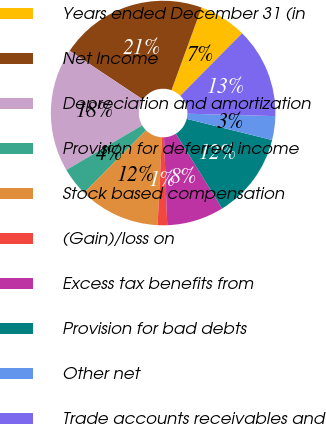<chart> <loc_0><loc_0><loc_500><loc_500><pie_chart><fcel>Years ended December 31 (in<fcel>Net Income<fcel>Depreciation and amortization<fcel>Provision for deferred income<fcel>Stock based compensation<fcel>(Gain)/loss on<fcel>Excess tax benefits from<fcel>Provision for bad debts<fcel>Other net<fcel>Trade accounts receivables and<nl><fcel>6.85%<fcel>21.23%<fcel>17.81%<fcel>4.11%<fcel>11.64%<fcel>1.37%<fcel>8.22%<fcel>12.33%<fcel>3.43%<fcel>13.01%<nl></chart> 